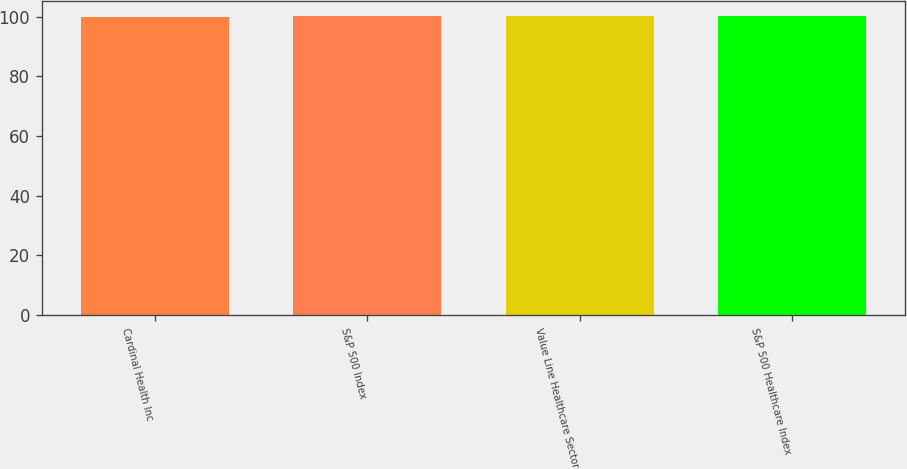Convert chart to OTSL. <chart><loc_0><loc_0><loc_500><loc_500><bar_chart><fcel>Cardinal Health Inc<fcel>S&P 500 Index<fcel>Value Line Healthcare Sector<fcel>S&P 500 Healthcare Index<nl><fcel>100<fcel>100.1<fcel>100.2<fcel>100.3<nl></chart> 